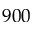Convert formula to latex. <formula><loc_0><loc_0><loc_500><loc_500>9 0 0</formula> 